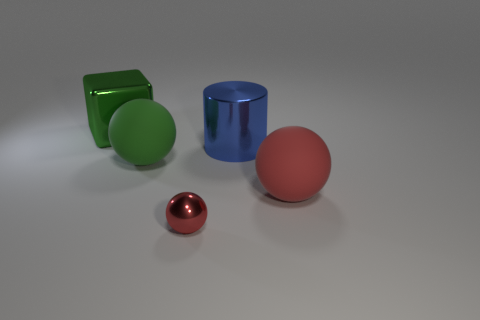There is a green cube that is the same size as the green ball; what is its material?
Offer a very short reply. Metal. Are there any blue things that have the same shape as the tiny red thing?
Make the answer very short. No. There is a thing that is the same color as the big cube; what is its material?
Offer a terse response. Rubber. There is a green object in front of the metallic block; what is its shape?
Make the answer very short. Sphere. How many rubber cubes are there?
Provide a succinct answer. 0. There is a small sphere that is made of the same material as the large green cube; what is its color?
Ensure brevity in your answer.  Red. What number of small things are either green objects or purple spheres?
Your answer should be very brief. 0. How many small red objects are right of the red rubber ball?
Ensure brevity in your answer.  0. The other large thing that is the same shape as the green matte thing is what color?
Offer a very short reply. Red. What number of rubber objects are cyan things or green balls?
Keep it short and to the point. 1. 